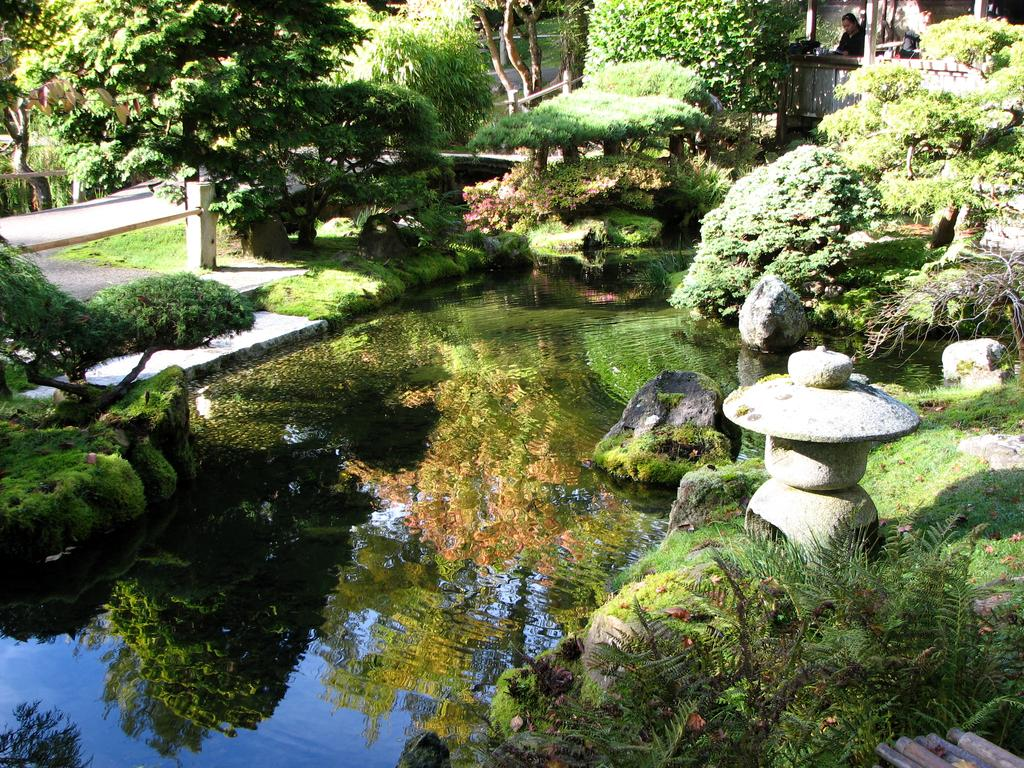What type of natural elements can be seen in the image? There are trees and plants in the image. What is located in the middle of the image? There is a pond in the middle of the image. Can you describe the person in the image? There is a person in the top right of the image. What type of rabbit can be seen holding a note in the image? There is no rabbit or note present in the image. What mathematical operation is being performed by the person in the image? The image does not show the person performing any mathematical operation. 